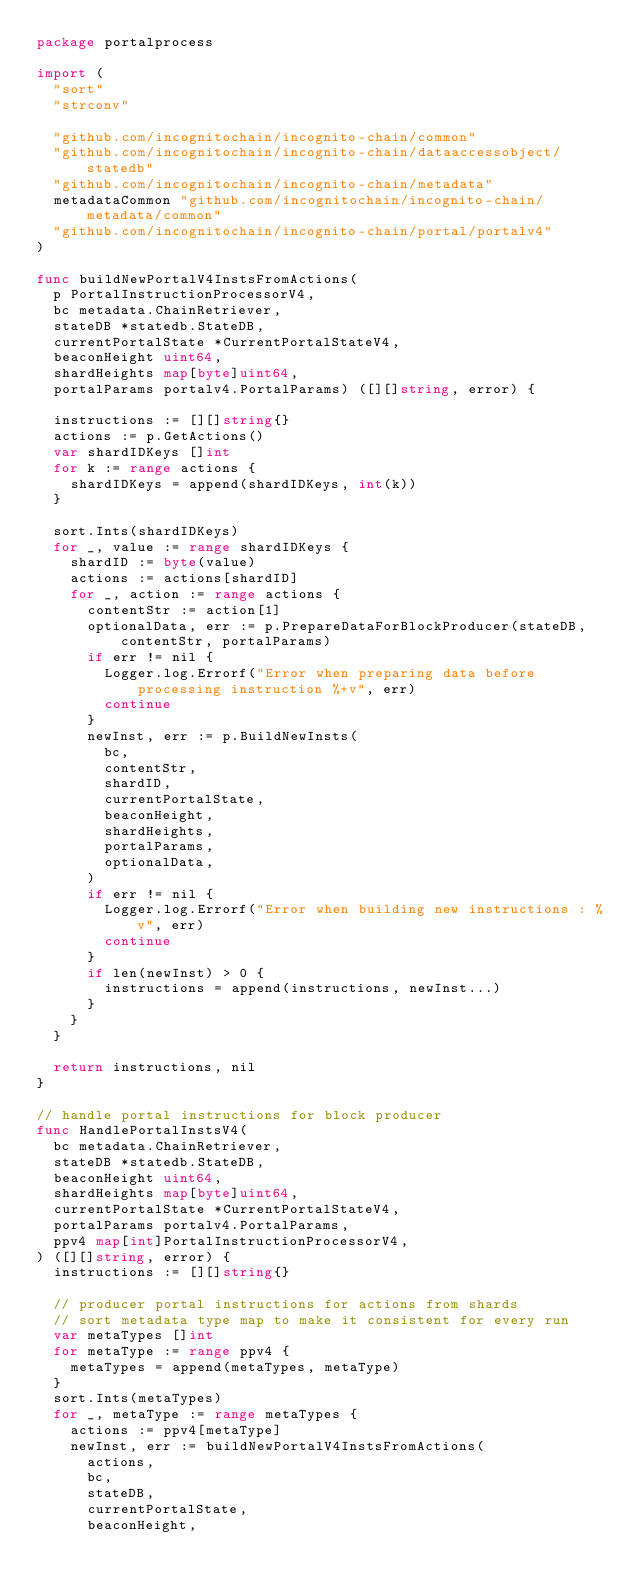<code> <loc_0><loc_0><loc_500><loc_500><_Go_>package portalprocess

import (
	"sort"
	"strconv"

	"github.com/incognitochain/incognito-chain/common"
	"github.com/incognitochain/incognito-chain/dataaccessobject/statedb"
	"github.com/incognitochain/incognito-chain/metadata"
	metadataCommon "github.com/incognitochain/incognito-chain/metadata/common"
	"github.com/incognitochain/incognito-chain/portal/portalv4"
)

func buildNewPortalV4InstsFromActions(
	p PortalInstructionProcessorV4,
	bc metadata.ChainRetriever,
	stateDB *statedb.StateDB,
	currentPortalState *CurrentPortalStateV4,
	beaconHeight uint64,
	shardHeights map[byte]uint64,
	portalParams portalv4.PortalParams) ([][]string, error) {

	instructions := [][]string{}
	actions := p.GetActions()
	var shardIDKeys []int
	for k := range actions {
		shardIDKeys = append(shardIDKeys, int(k))
	}

	sort.Ints(shardIDKeys)
	for _, value := range shardIDKeys {
		shardID := byte(value)
		actions := actions[shardID]
		for _, action := range actions {
			contentStr := action[1]
			optionalData, err := p.PrepareDataForBlockProducer(stateDB, contentStr, portalParams)
			if err != nil {
				Logger.log.Errorf("Error when preparing data before processing instruction %+v", err)
				continue
			}
			newInst, err := p.BuildNewInsts(
				bc,
				contentStr,
				shardID,
				currentPortalState,
				beaconHeight,
				shardHeights,
				portalParams,
				optionalData,
			)
			if err != nil {
				Logger.log.Errorf("Error when building new instructions : %v", err)
				continue
			}
			if len(newInst) > 0 {
				instructions = append(instructions, newInst...)
			}
		}
	}

	return instructions, nil
}

// handle portal instructions for block producer
func HandlePortalInstsV4(
	bc metadata.ChainRetriever,
	stateDB *statedb.StateDB,
	beaconHeight uint64,
	shardHeights map[byte]uint64,
	currentPortalState *CurrentPortalStateV4,
	portalParams portalv4.PortalParams,
	ppv4 map[int]PortalInstructionProcessorV4,
) ([][]string, error) {
	instructions := [][]string{}

	// producer portal instructions for actions from shards
	// sort metadata type map to make it consistent for every run
	var metaTypes []int
	for metaType := range ppv4 {
		metaTypes = append(metaTypes, metaType)
	}
	sort.Ints(metaTypes)
	for _, metaType := range metaTypes {
		actions := ppv4[metaType]
		newInst, err := buildNewPortalV4InstsFromActions(
			actions,
			bc,
			stateDB,
			currentPortalState,
			beaconHeight,</code> 